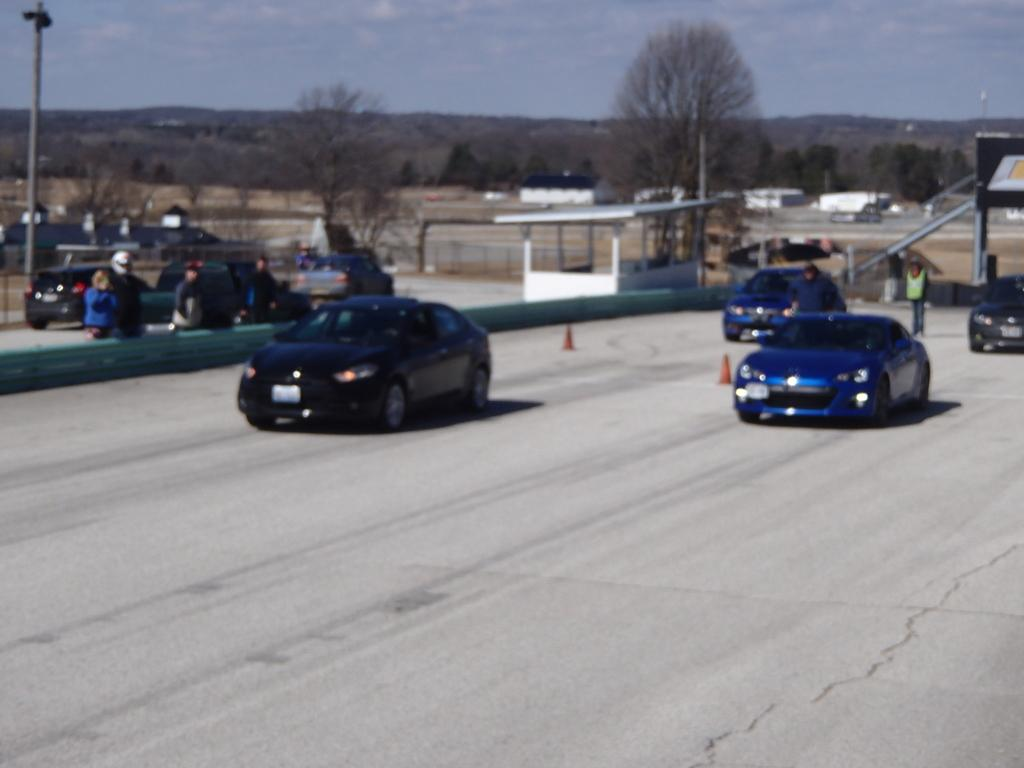What is present on the road in the image? There are vehicles on the road in the image. What can be seen in the distance behind the vehicles? There are trees visible in the background of the image. What else is visible in the background of the image? The sky is visible in the background of the image. Where is the worm located in the image? There is no worm present in the image. What does the dad do in the image? There is no dad present in the image. 